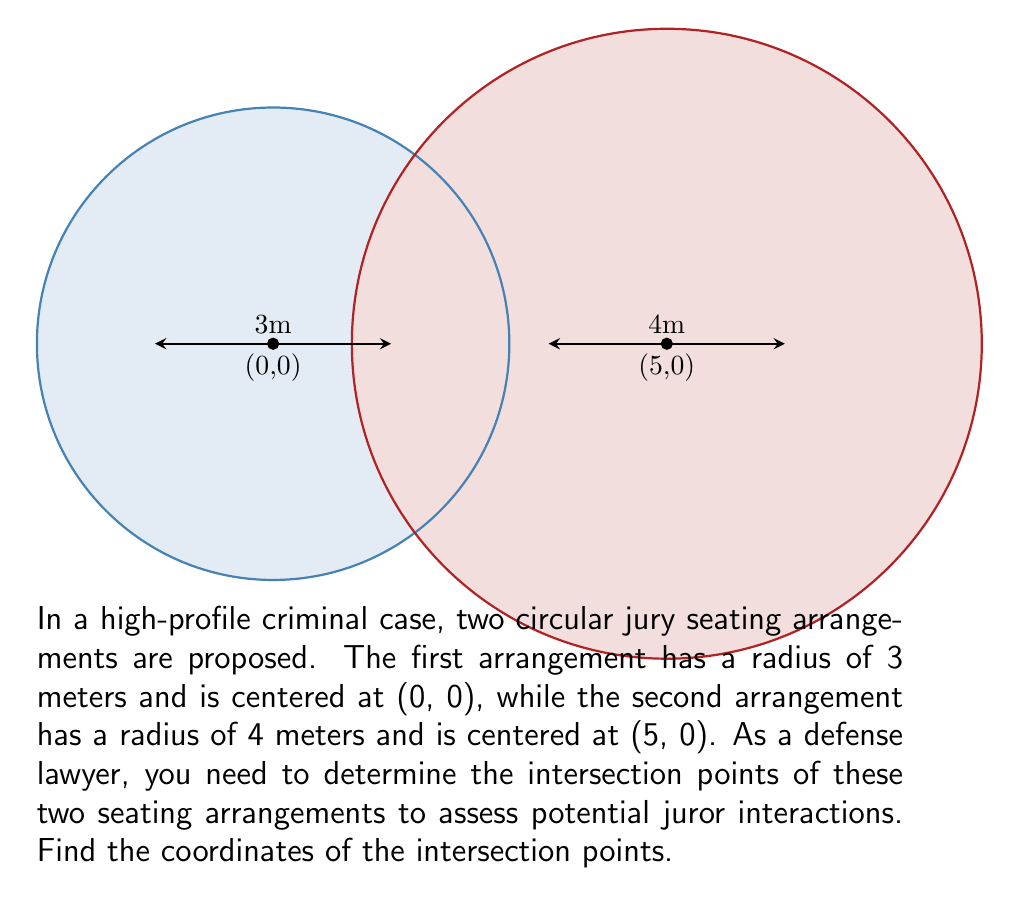Help me with this question. To find the intersection points of two circles, we can follow these steps:

1) The equations of the two circles are:

   Circle 1: $x^2 + y^2 = 9$ (radius 3, center at origin)
   Circle 2: $(x-5)^2 + y^2 = 16$ (radius 4, center at (5,0))

2) To find the intersection points, we need to solve these equations simultaneously.

3) Expand the second equation:
   $x^2 - 10x + 25 + y^2 = 16$
   $x^2 - 10x + y^2 = -9$

4) Subtract the first equation from this:
   $-10x = -18$
   $x = 1.8$

5) Substitute this x-value back into the equation of the first circle:
   $(1.8)^2 + y^2 = 9$
   $3.24 + y^2 = 9$
   $y^2 = 5.76$
   $y = \pm 2.4$

6) Therefore, the intersection points are (1.8, 2.4) and (1.8, -2.4).

7) We can verify these points satisfy both circle equations:

   For (1.8, 2.4):
   $1.8^2 + 2.4^2 = 3.24 + 5.76 = 9$
   $(1.8-5)^2 + 2.4^2 = (-3.2)^2 + 5.76 = 10.24 + 5.76 = 16$

   Similarly for (1.8, -2.4).
Answer: (1.8, 2.4) and (1.8, -2.4) 